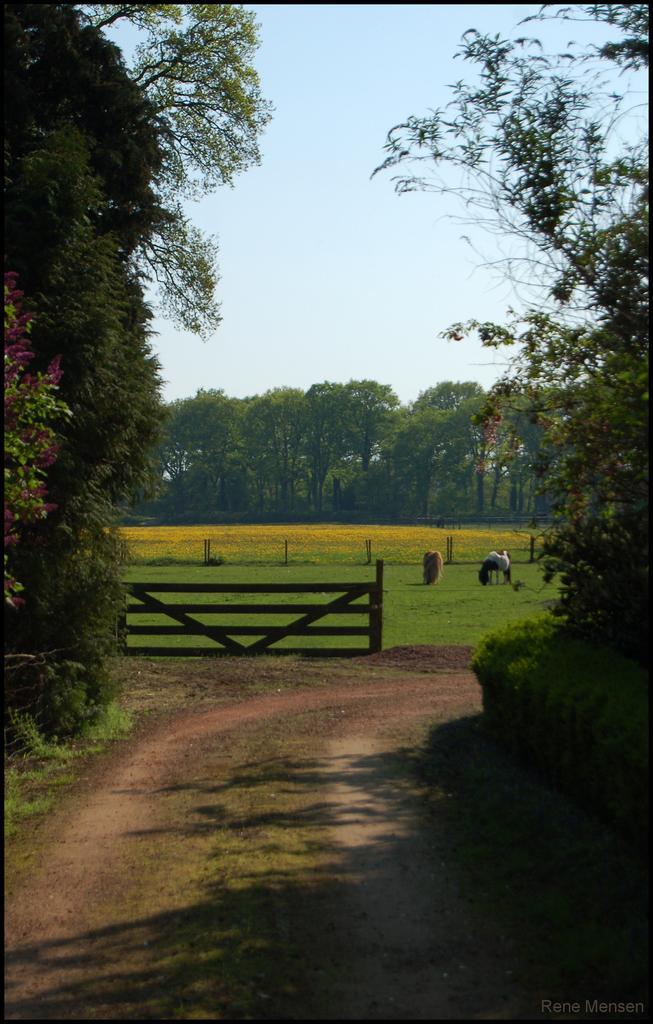Please provide a concise description of this image. In this picture there are trees. In the foreground there is a wooden railing and there are animals standing on the grass. At the top there is sky. At the bottom there is grass and there is ground and there are plants. 